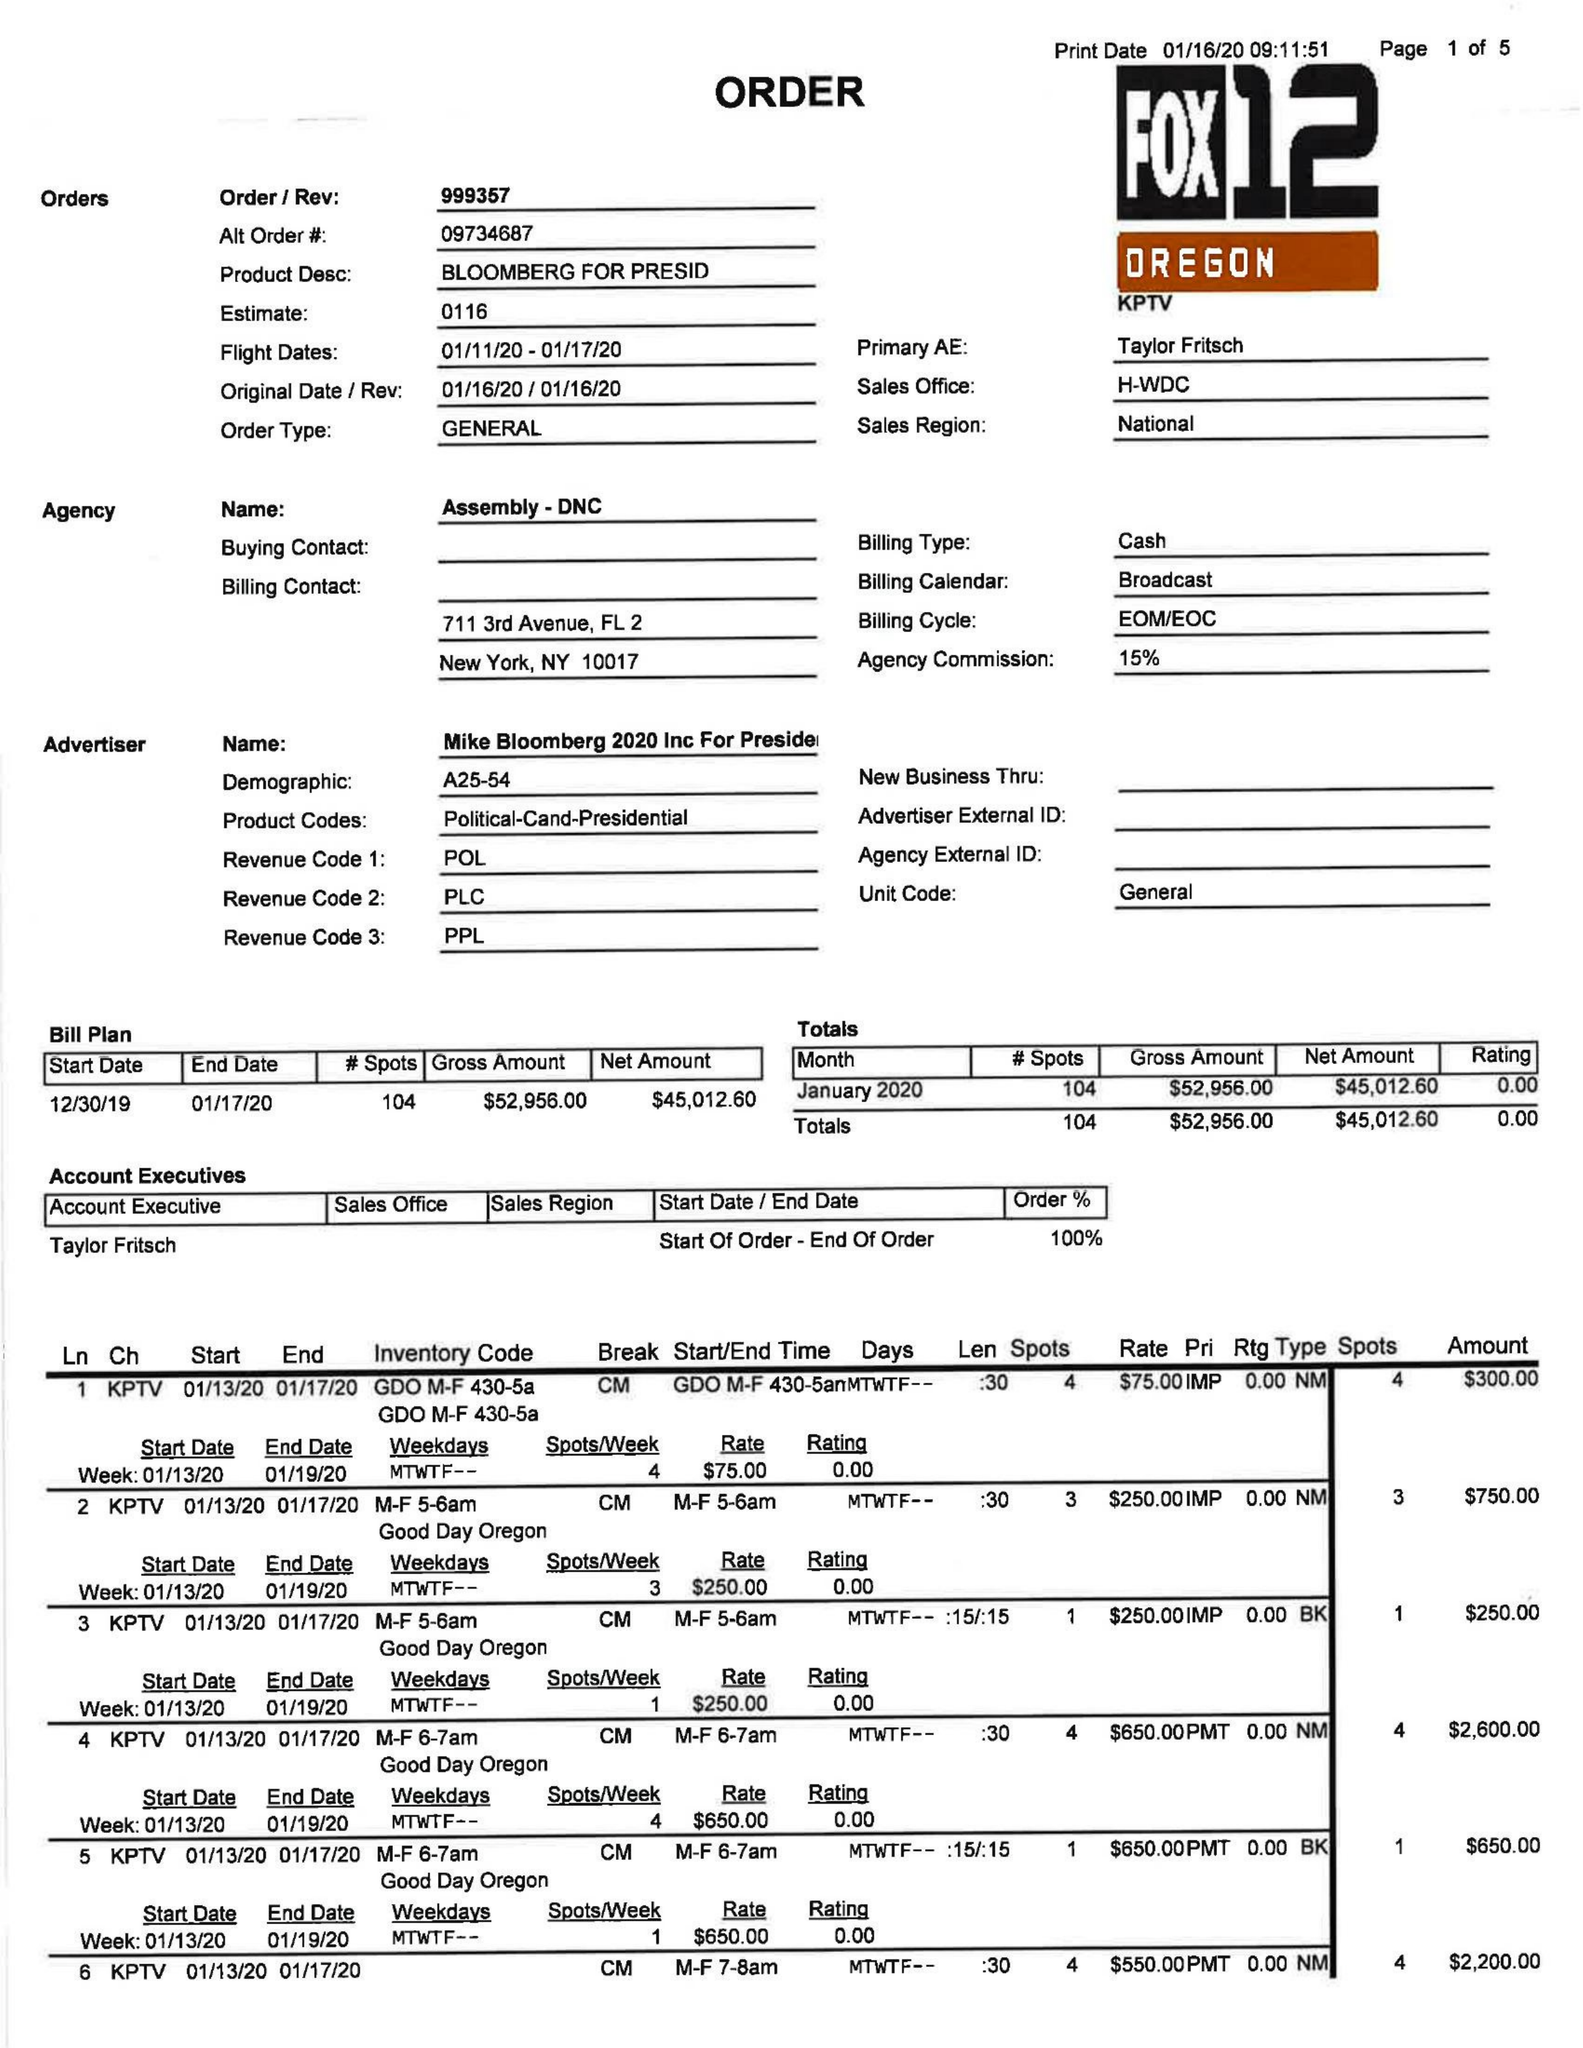What is the value for the gross_amount?
Answer the question using a single word or phrase. 52956.00 